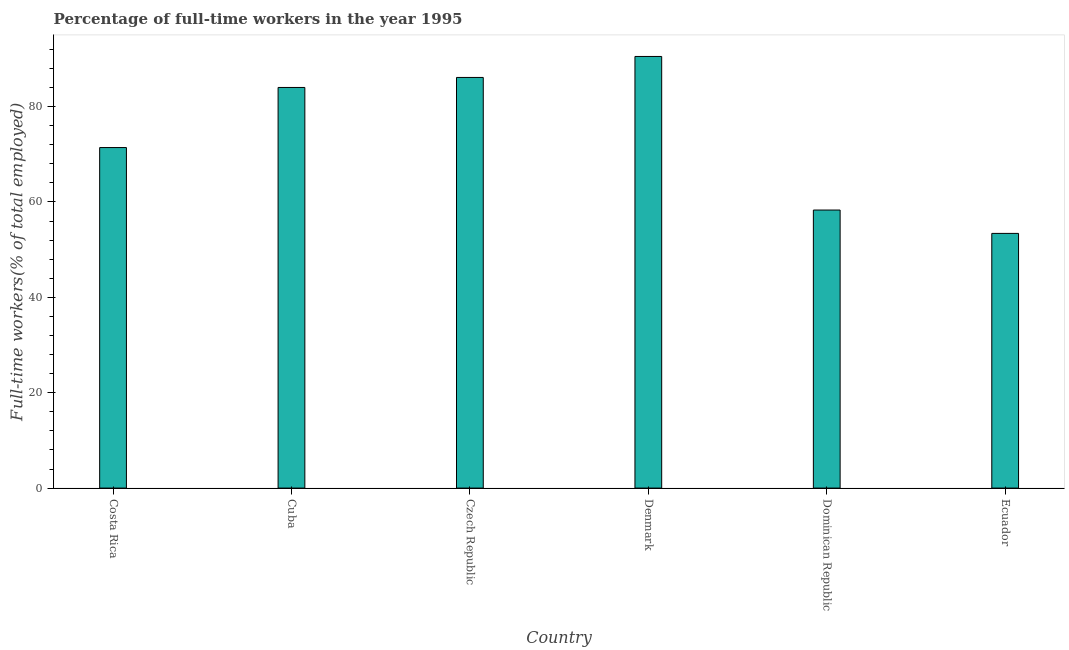Does the graph contain any zero values?
Ensure brevity in your answer.  No. What is the title of the graph?
Provide a short and direct response. Percentage of full-time workers in the year 1995. What is the label or title of the Y-axis?
Provide a short and direct response. Full-time workers(% of total employed). What is the percentage of full-time workers in Denmark?
Offer a very short reply. 90.5. Across all countries, what is the maximum percentage of full-time workers?
Offer a very short reply. 90.5. Across all countries, what is the minimum percentage of full-time workers?
Your answer should be very brief. 53.4. In which country was the percentage of full-time workers maximum?
Give a very brief answer. Denmark. In which country was the percentage of full-time workers minimum?
Make the answer very short. Ecuador. What is the sum of the percentage of full-time workers?
Offer a very short reply. 443.7. What is the difference between the percentage of full-time workers in Denmark and Dominican Republic?
Your answer should be compact. 32.2. What is the average percentage of full-time workers per country?
Your response must be concise. 73.95. What is the median percentage of full-time workers?
Your answer should be compact. 77.7. What is the ratio of the percentage of full-time workers in Cuba to that in Ecuador?
Make the answer very short. 1.57. Is the percentage of full-time workers in Dominican Republic less than that in Ecuador?
Provide a succinct answer. No. Is the difference between the percentage of full-time workers in Czech Republic and Denmark greater than the difference between any two countries?
Offer a very short reply. No. What is the difference between the highest and the lowest percentage of full-time workers?
Your response must be concise. 37.1. In how many countries, is the percentage of full-time workers greater than the average percentage of full-time workers taken over all countries?
Your answer should be very brief. 3. How many bars are there?
Ensure brevity in your answer.  6. How many countries are there in the graph?
Provide a short and direct response. 6. What is the difference between two consecutive major ticks on the Y-axis?
Your response must be concise. 20. What is the Full-time workers(% of total employed) in Costa Rica?
Your response must be concise. 71.4. What is the Full-time workers(% of total employed) in Cuba?
Ensure brevity in your answer.  84. What is the Full-time workers(% of total employed) in Czech Republic?
Give a very brief answer. 86.1. What is the Full-time workers(% of total employed) in Denmark?
Your answer should be compact. 90.5. What is the Full-time workers(% of total employed) in Dominican Republic?
Make the answer very short. 58.3. What is the Full-time workers(% of total employed) in Ecuador?
Your response must be concise. 53.4. What is the difference between the Full-time workers(% of total employed) in Costa Rica and Czech Republic?
Provide a short and direct response. -14.7. What is the difference between the Full-time workers(% of total employed) in Costa Rica and Denmark?
Provide a short and direct response. -19.1. What is the difference between the Full-time workers(% of total employed) in Costa Rica and Ecuador?
Offer a very short reply. 18. What is the difference between the Full-time workers(% of total employed) in Cuba and Czech Republic?
Offer a terse response. -2.1. What is the difference between the Full-time workers(% of total employed) in Cuba and Dominican Republic?
Provide a succinct answer. 25.7. What is the difference between the Full-time workers(% of total employed) in Cuba and Ecuador?
Your response must be concise. 30.6. What is the difference between the Full-time workers(% of total employed) in Czech Republic and Denmark?
Keep it short and to the point. -4.4. What is the difference between the Full-time workers(% of total employed) in Czech Republic and Dominican Republic?
Your response must be concise. 27.8. What is the difference between the Full-time workers(% of total employed) in Czech Republic and Ecuador?
Your answer should be compact. 32.7. What is the difference between the Full-time workers(% of total employed) in Denmark and Dominican Republic?
Provide a succinct answer. 32.2. What is the difference between the Full-time workers(% of total employed) in Denmark and Ecuador?
Keep it short and to the point. 37.1. What is the difference between the Full-time workers(% of total employed) in Dominican Republic and Ecuador?
Ensure brevity in your answer.  4.9. What is the ratio of the Full-time workers(% of total employed) in Costa Rica to that in Czech Republic?
Provide a short and direct response. 0.83. What is the ratio of the Full-time workers(% of total employed) in Costa Rica to that in Denmark?
Keep it short and to the point. 0.79. What is the ratio of the Full-time workers(% of total employed) in Costa Rica to that in Dominican Republic?
Provide a short and direct response. 1.23. What is the ratio of the Full-time workers(% of total employed) in Costa Rica to that in Ecuador?
Your answer should be very brief. 1.34. What is the ratio of the Full-time workers(% of total employed) in Cuba to that in Denmark?
Your answer should be very brief. 0.93. What is the ratio of the Full-time workers(% of total employed) in Cuba to that in Dominican Republic?
Your response must be concise. 1.44. What is the ratio of the Full-time workers(% of total employed) in Cuba to that in Ecuador?
Your response must be concise. 1.57. What is the ratio of the Full-time workers(% of total employed) in Czech Republic to that in Denmark?
Your response must be concise. 0.95. What is the ratio of the Full-time workers(% of total employed) in Czech Republic to that in Dominican Republic?
Provide a short and direct response. 1.48. What is the ratio of the Full-time workers(% of total employed) in Czech Republic to that in Ecuador?
Offer a terse response. 1.61. What is the ratio of the Full-time workers(% of total employed) in Denmark to that in Dominican Republic?
Provide a succinct answer. 1.55. What is the ratio of the Full-time workers(% of total employed) in Denmark to that in Ecuador?
Give a very brief answer. 1.7. What is the ratio of the Full-time workers(% of total employed) in Dominican Republic to that in Ecuador?
Offer a very short reply. 1.09. 